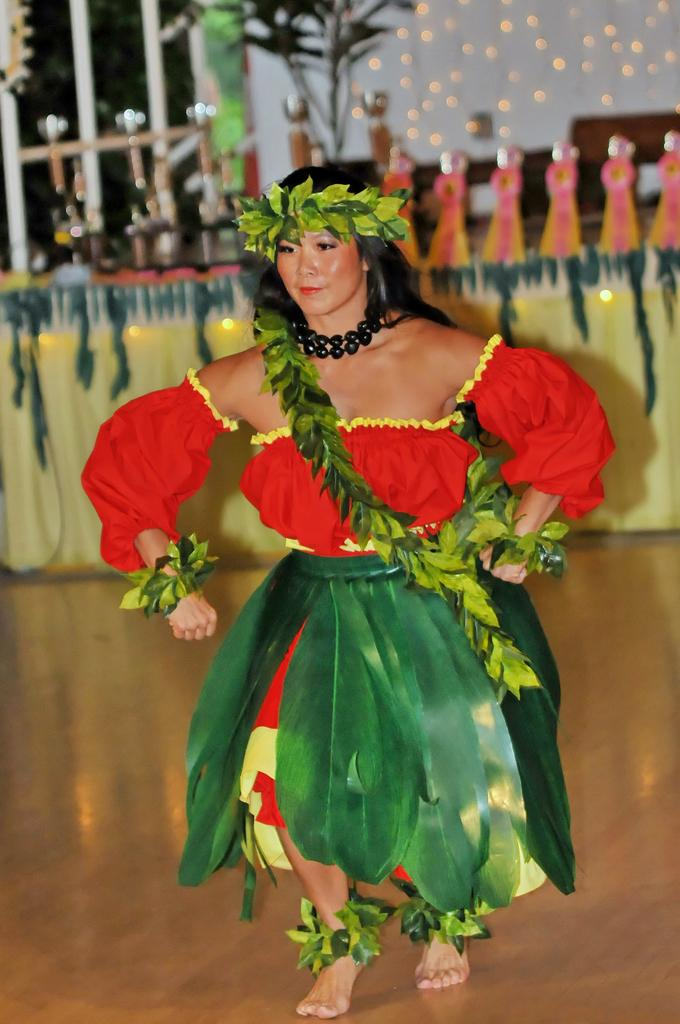Who is present in the image? There is a woman in the image. What is the woman wearing? The woman is wearing a white dress. What furniture can be seen in the image? There is a table in the image. What architectural feature is visible in the image? There is a window in the image. What type of plant is present in the image? There is a plant in the image. What type of lighting is present in the image? There are lights in the image. What color is the wall in the image? There is a white color wall in the image. How many boys are visible in the image? There are no boys present in the image; it features a woman. What type of grape is being used as a decoration on the woman's dress? There is no grape present on the woman's dress in the image. 